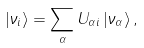<formula> <loc_0><loc_0><loc_500><loc_500>\left | \nu _ { i } \right \rangle = \sum _ { \alpha } U _ { \alpha i } \left | \nu _ { \alpha } \right \rangle ,</formula> 